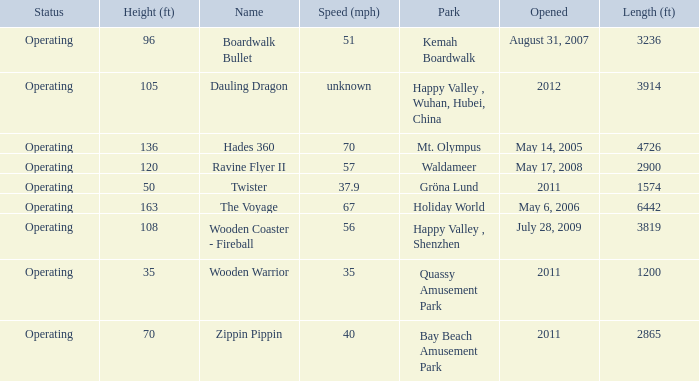How fast is the coaster that is 163 feet tall 67.0. 